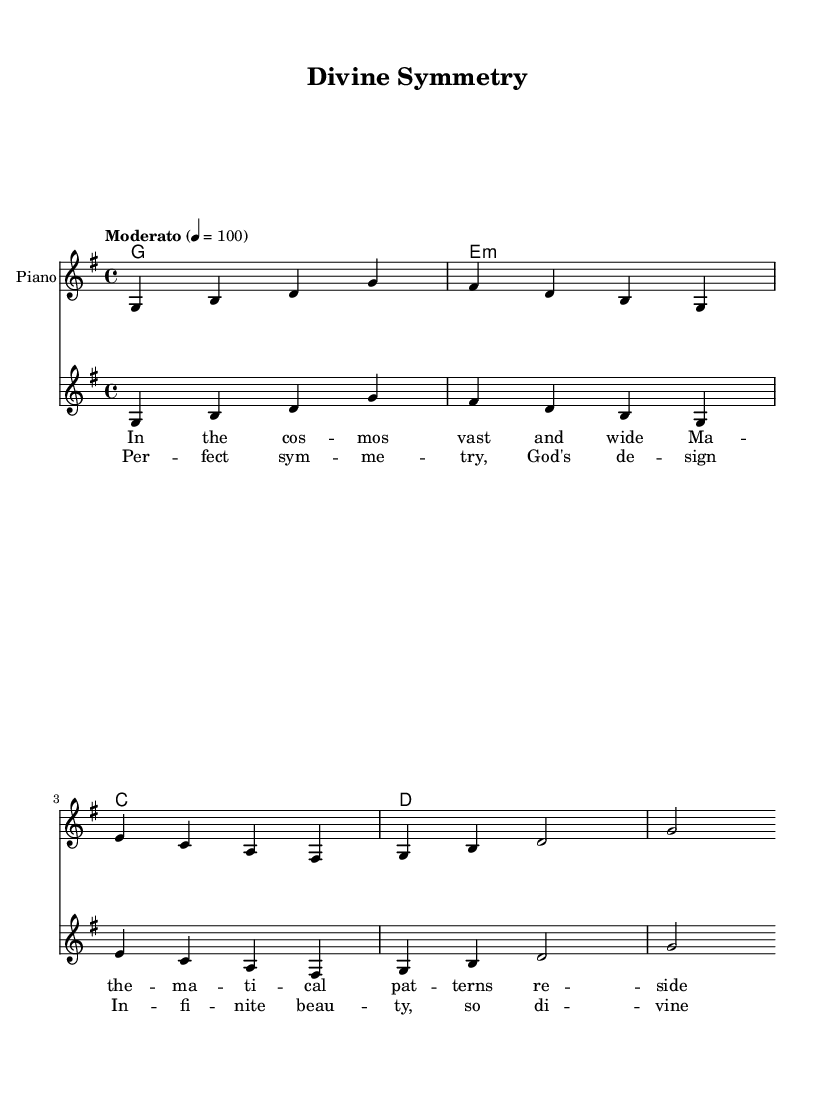What is the key signature of this music? The key signature is G major, which has one sharp (F#). This can be determined by looking at the key signature indicated at the beginning of the staff.
Answer: G major What is the time signature of the piece? The time signature is 4/4, which means there are four beats in each measure and the quarter note gets one beat. This is indicated at the beginning of the score.
Answer: 4/4 What is the tempo marking for this piece? The tempo marking is "Moderato," which indicates a moderate tempo, often interpreted as a moderate walking pace. This is found at the beginning of the score, under the tempo directive.
Answer: Moderato How many measures are in the melody? The melody consists of four measures, which can be counted by looking at the vertical lines dividing the measures.
Answer: Four measures In which part of the music do the lyrics about cosmic harmony appear? The lyrics about cosmic harmony appear in the chorus section, which conveys themes of divine design and infinite beauty. This can be inferred by identifying the section labeled “chorus” below the melody.
Answer: Chorus What are the first three notes of the melody? The first three notes of the melody are G, B, and D, seen at the beginning of the melody line written in the staff.
Answer: G, B, D What chord is associated with the first measure of the harmonies? The chord associated with the first measure is G major, which is indicated in the chord names section above the staff.
Answer: G major 